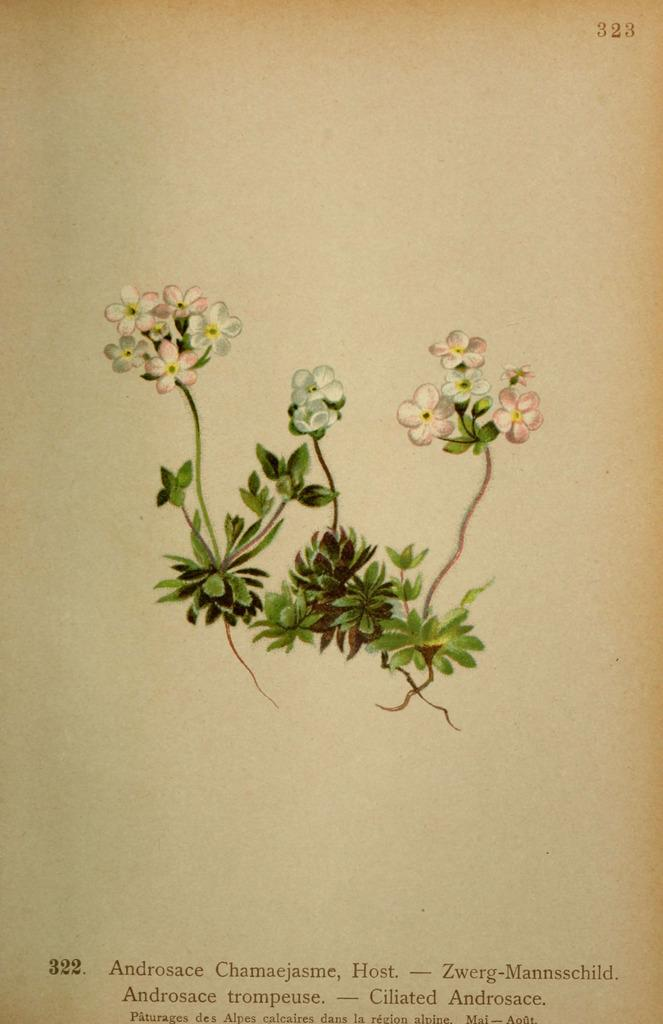What is depicted on the paper in the image? The paper has flowers drawn on it. What colors are used for the flowers on the paper? The flowers are in pink and white colors. Are there any other elements drawn on the paper besides flowers? Yes, there are leaves drawn on the paper. What color are the leaves on the paper? The leaves are in green color. Is there any text or writing on the paper? Yes, there is writing on the paper. Can you see a cactus in the image? No, there is no cactus present in the image. What type of tank is visible in the image? There is no tank present in the image. 